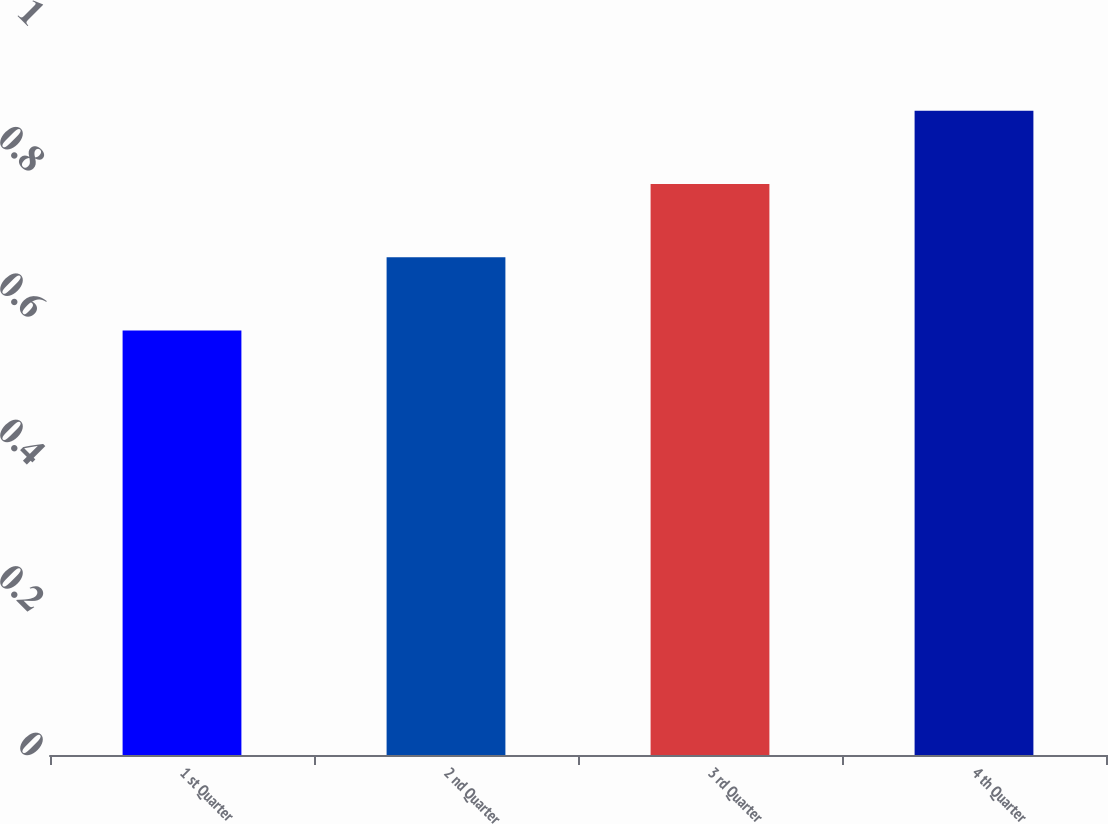Convert chart to OTSL. <chart><loc_0><loc_0><loc_500><loc_500><bar_chart><fcel>1 st Quarter<fcel>2 nd Quarter<fcel>3 rd Quarter<fcel>4 th Quarter<nl><fcel>0.58<fcel>0.68<fcel>0.78<fcel>0.88<nl></chart> 